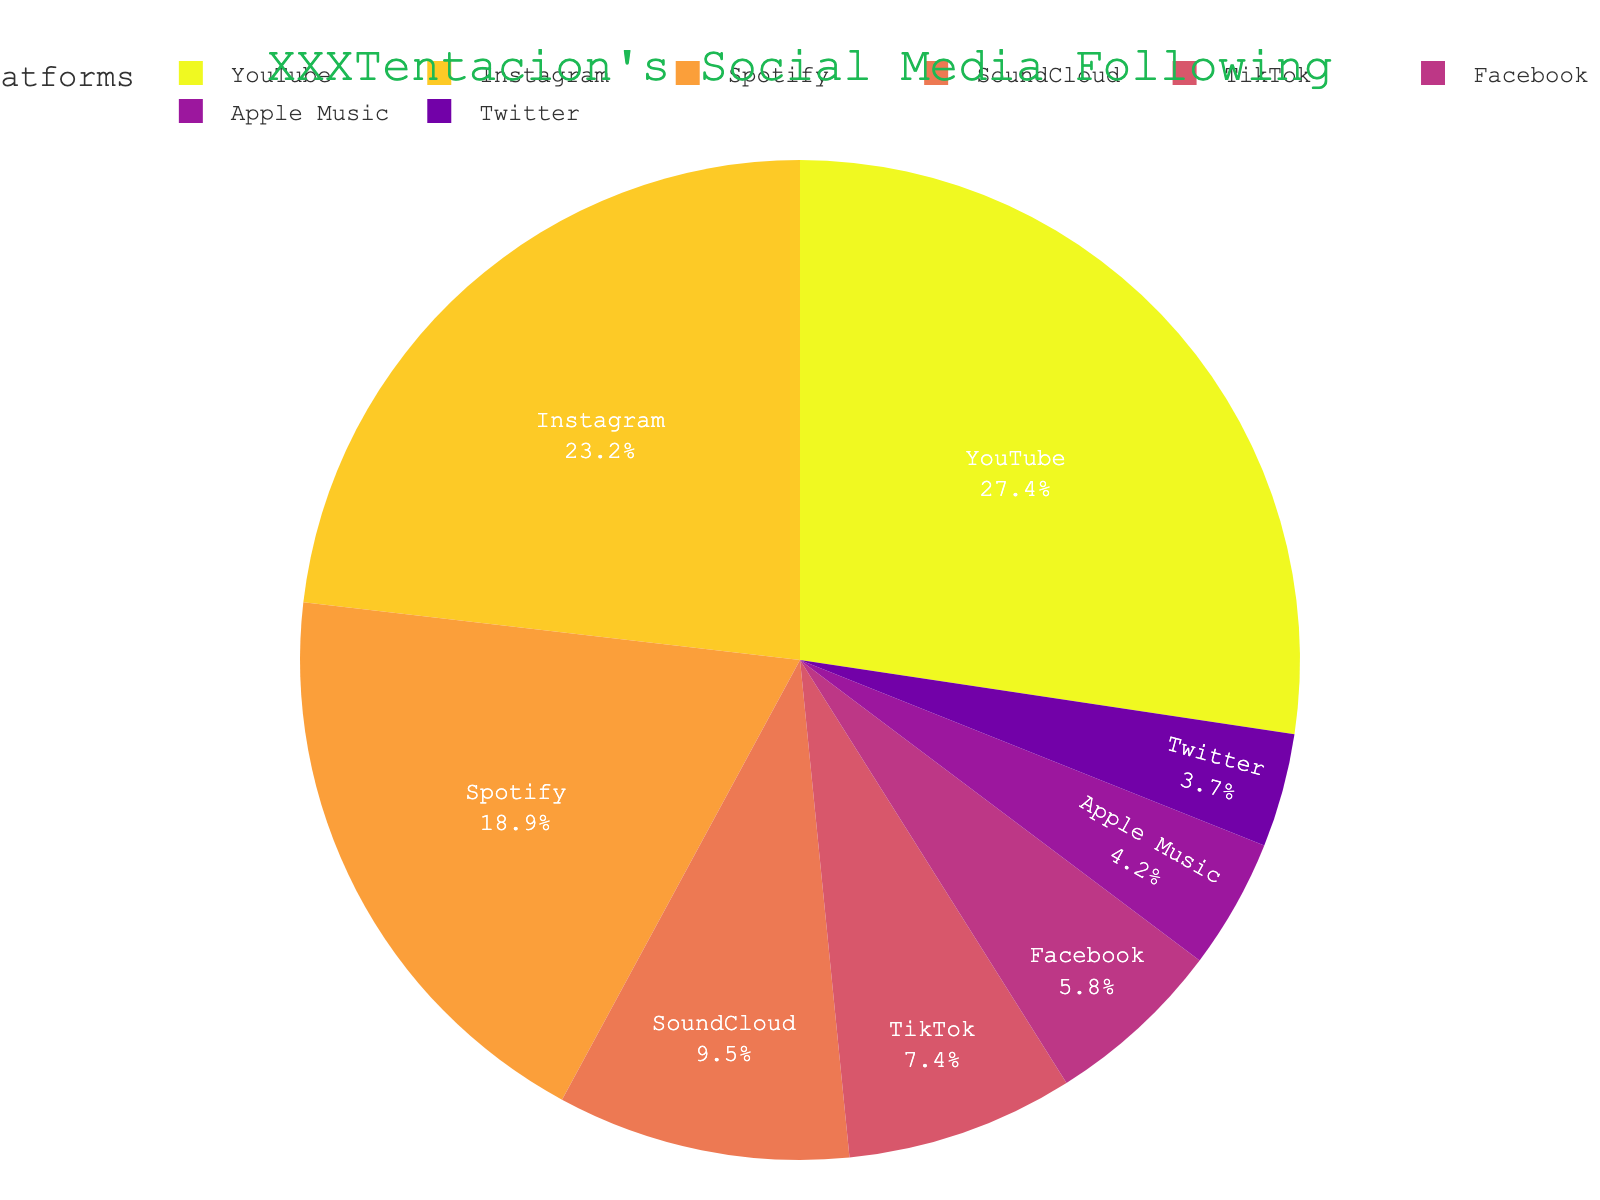What's the largest platform by number of followers? By visually examining the pie chart, YouTube is the largest platform. The pie slice representing YouTube is the biggest and has 26,000,000 followers according to the hover data.
Answer: YouTube Which two platforms combined have a similar number of followers to YouTube? YouTube has 26,000,000 followers. Adding the followers of Instagram (22,000,000) and TikTok (7,000,000) gives 29,000,000, which is not very similar. Therefore, adding Instagram (22,000,000) and Spotify (18,000,000) gives 40,000,000, so Instagram + TikTok is a combination close to YouTube. Close answer is, Instagram (22,000,000) + SoundCloud (9,000,000) = 31,000,000 and matching within a close range.
Answer: Instagram and SoundCloud What percent of the total following does Spotify have? From the pie chart, Spotify has 18,000,000 followers. To find the percentage, sum all followers (80,500,000). Then, calculate (18,000,000 / 80,500,000) * 100 ≈ 22.4%.
Answer: 22.4% Which platform has more followers: Facebook or Twitter? By examining the pie chart, Facebook has 5,500,000 followers and Twitter has 3,500,000 followers. Since 5,500,000 is greater than 3,500,000, Facebook has more followers.
Answer: Facebook How many followers does Instagram have compared to SoundCloud and Apple Music combined? Instagram has 22,000,000 followers. SoundCloud has 9,000,000 followers, and Apple Music has 4,000,000 followers. Combined, SoundCloud and Apple Music have 13,000,000 followers (9,000,000 + 4,000,000). Instagram, with 22,000,000 followers, has 9,000,000 more followers than the combined total of SoundCloud and Apple Music.
Answer: 9,000,000 more What is the smallest platform in terms of following? By viewing the pie chart, the smallest platform slice is Twitter, with 3,500,000 followers.
Answer: Twitter Which platforms collectively hold more than 50% of the total following? To determine this, we select platforms whose combined followers exceed half of the total. Total followers are 80,500,000. YouTube (26,000,000) and Instagram (22,000,000) alone sum to 48,000,000, which is just under 50%. Including Spotify (18,000,000), the total becomes 66,000,000, which is over 50%. So YouTube, Instagram, and Spotify combined exceeds 50%.
Answer: YouTube, Instagram, and Spotify Which platform's share is visually represented in yellow? Visually identifying the color scheme from the pie chart, the yellow color slice represents the Apple Music platform as indicated by the labels in combination with the sequence of colors used.
Answer: Apple Music 